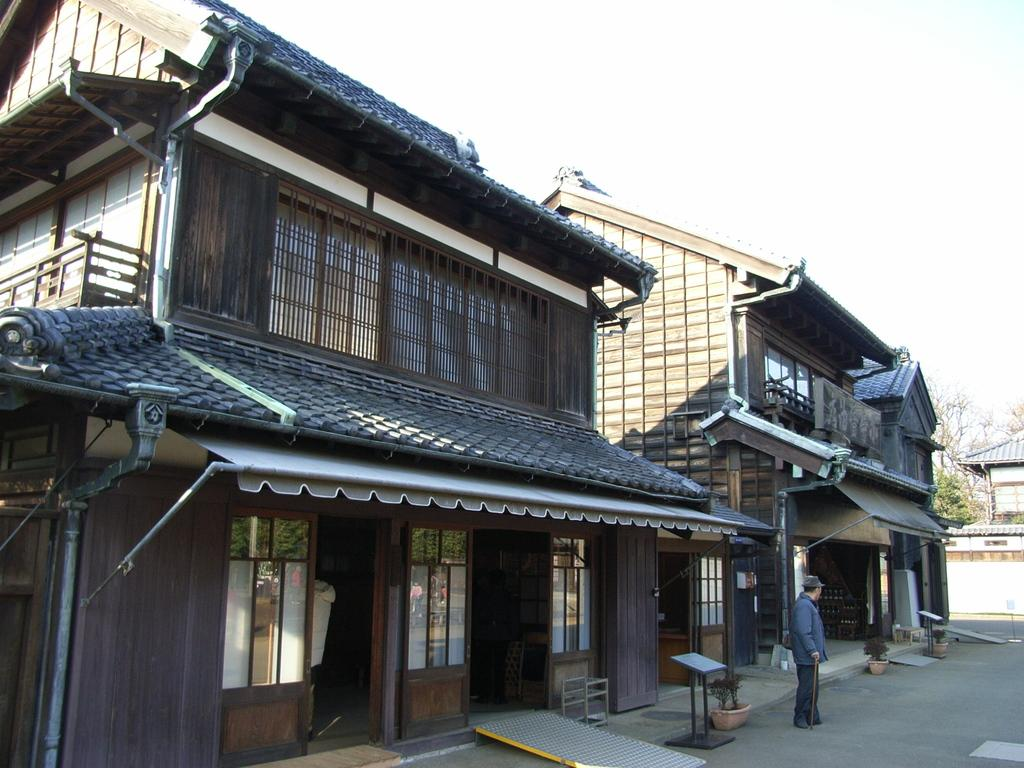What type of structures are visible in the image? There are buildings with windows in the image. Can you describe the person in the image? There is a person standing in front of a building, and they are holding a stick. What can be seen in the background of the image? There are trees, a board, and the sky visible in the background of the image. What color are the person's eyes in the image? The provided facts do not mention the person's eyes, so we cannot determine their color from the image. How many soap bars are visible on the person's wrist in the image? There is no soap or wrist visible in the image; the person is holding a stick. 